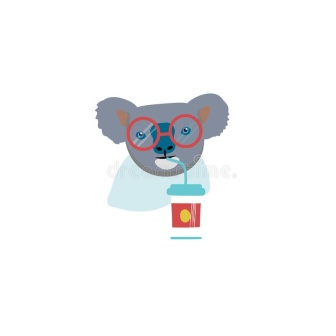Describe the following image. In the center of the image, a blue koala bear is the main subject. The koala, with its head slightly tilted to the left, is wearing a pair of red glasses that rest on its nose. The glasses are not only stylish but also seem to give the koala a scholarly look. 

The koala is engaged in the act of drinking, using a red and yellow striped straw. The straw is inserted into a red cup with a yellow lid, which the koala holds in its paws. The koala's eyes, looking towards the viewer, seem to invite us into this moment of refreshment.

The entire scene is set against a stark white background, which serves to highlight the colorful spectacle of the koala and its drink. The simplicity of the background ensures that the viewer's attention remains solely on the koala and its actions. 

Overall, the image captures a whimsical moment of a blue koala bear enjoying a drink, creating a playful and engaging visual narrative. 